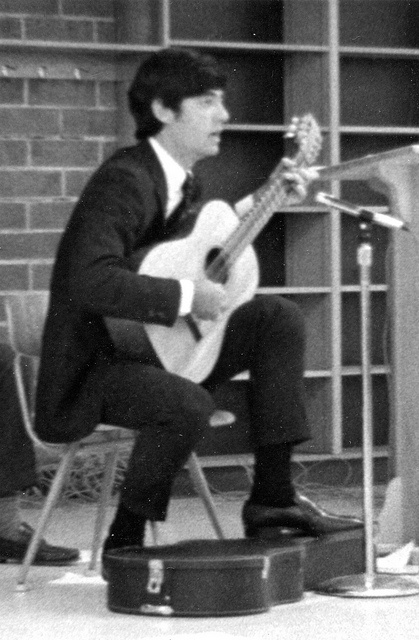Describe the objects in this image and their specific colors. I can see people in gray, black, darkgray, and lightgray tones, chair in gray, darkgray, black, and lightgray tones, people in gray, black, darkgray, and lightgray tones, and tie in black and gray tones in this image. 